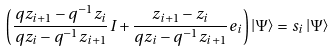<formula> <loc_0><loc_0><loc_500><loc_500>\left ( \frac { q z _ { i + 1 } - q ^ { - 1 } z _ { i } } { q z _ { i } - q ^ { - 1 } z _ { i + 1 } } I + \frac { z _ { i + 1 } - z _ { i } } { q z _ { i } - q ^ { - 1 } z _ { i + 1 } } e _ { i } \right ) \left | \Psi \right > = s _ { i } \left | \Psi \right ></formula> 